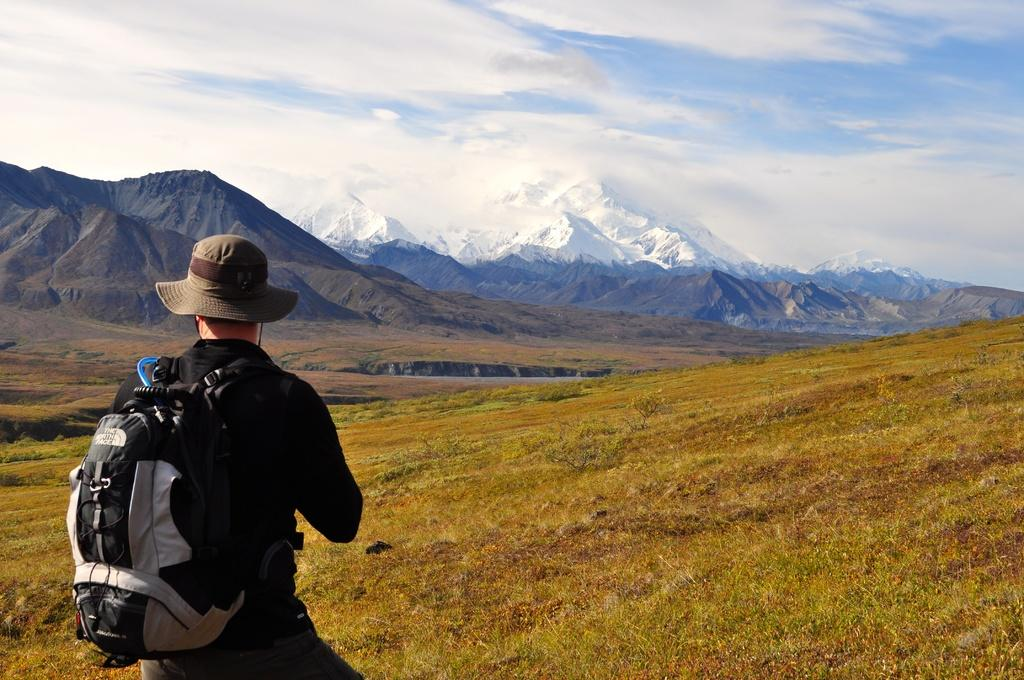What can be seen in the image? There is a person in the image. What is the person wearing on their head? The person is wearing a cap. What is the person carrying? The person is carrying a bag. What type of terrain is the person standing on? The person is standing on grass. What can be seen in the distance in the image? There are mountains visible in the background of the image. What is visible in the sky in the image? The sky is visible in the background of the image, and clouds are present. What type of paste is being used by the person in the image? There is no paste present in the image; the person is simply standing on grass and carrying a bag. 